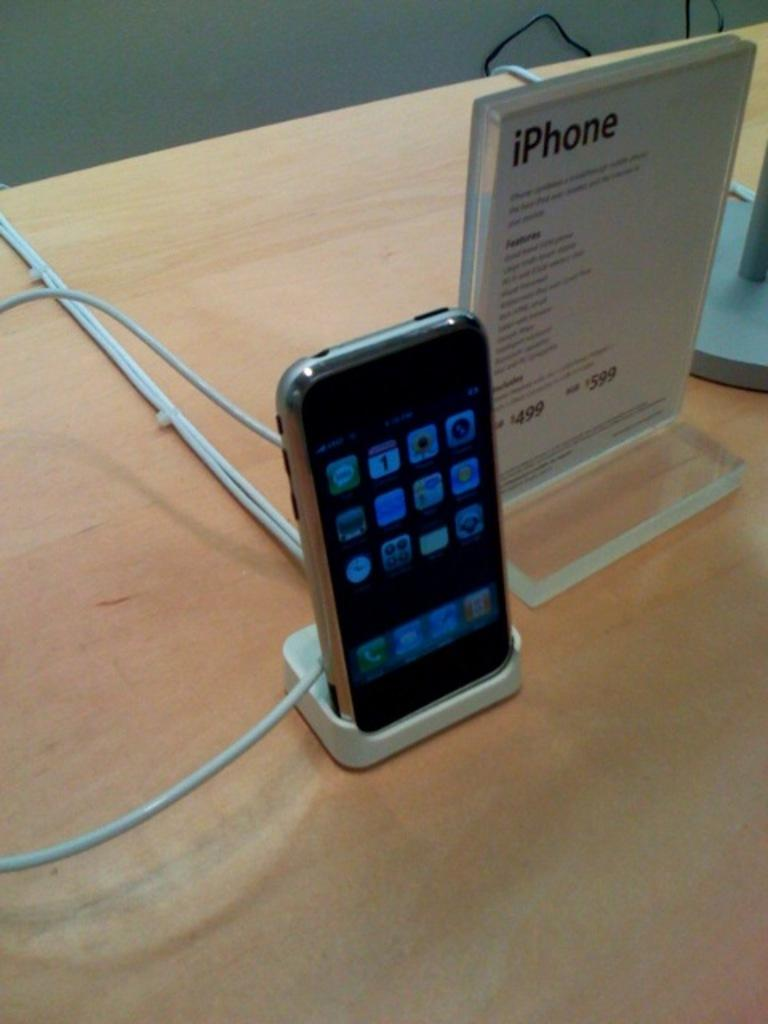<image>
Offer a succinct explanation of the picture presented. A cell phone sitting on a shelf with an sign saying IPhone on it. 